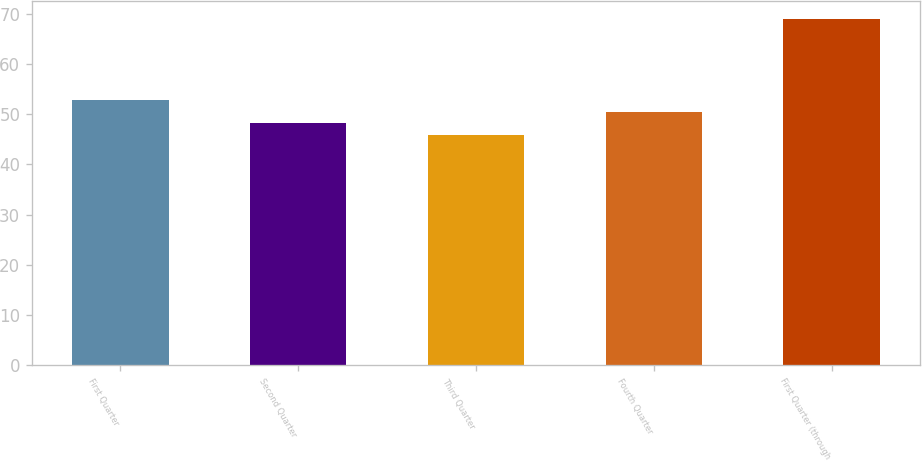Convert chart to OTSL. <chart><loc_0><loc_0><loc_500><loc_500><bar_chart><fcel>First Quarter<fcel>Second Quarter<fcel>Third Quarter<fcel>Fourth Quarter<fcel>First Quarter (through<nl><fcel>52.81<fcel>48.19<fcel>45.88<fcel>50.5<fcel>69<nl></chart> 